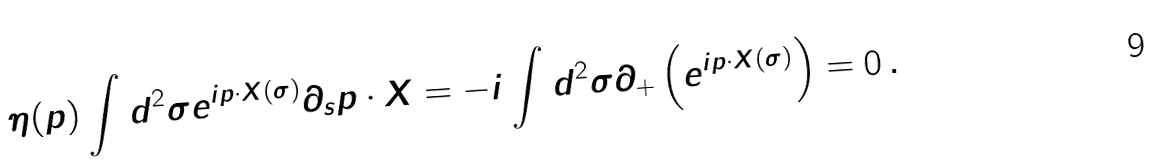Convert formula to latex. <formula><loc_0><loc_0><loc_500><loc_500>\eta ( p ) \int d ^ { 2 } \sigma e ^ { i p \cdot X ( \sigma ) } \partial _ { s } p \cdot X = - i \int d ^ { 2 } \sigma \partial _ { + } \left ( e ^ { i p \cdot X ( \sigma ) } \right ) = 0 \, .</formula> 